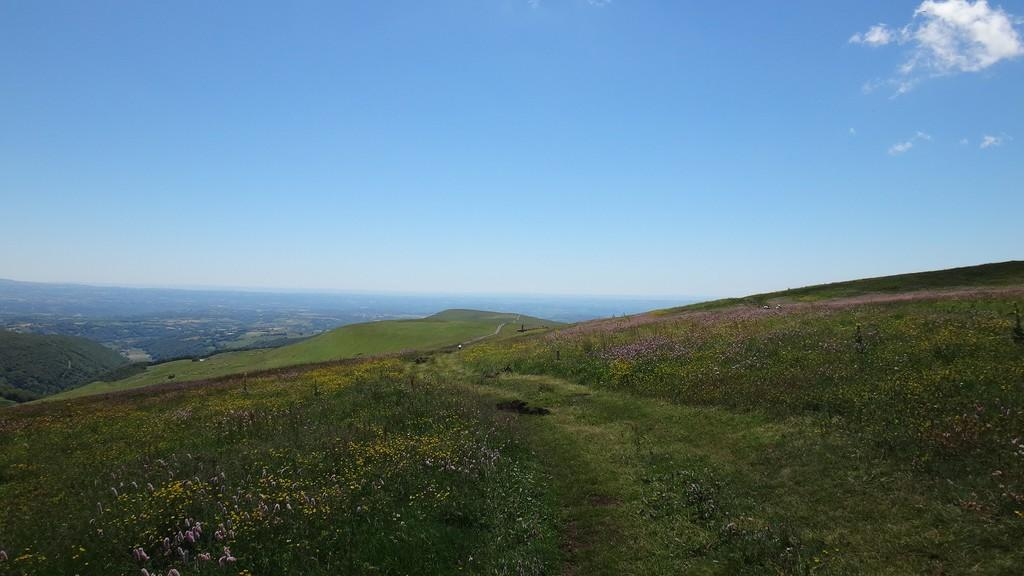What type of vegetation can be seen in the image? There are plants in the image. What type of ground cover is present in the image? There is grass in the image. What is visible at the top of the image? The sky is visible at the top of the image. How many icicles are hanging from the plants in the image? There are no icicles present in the image; it features plants and grass in a natural setting. What arithmetic problem is being solved by the plants in the image? There is no arithmetic problem being solved by the plants in the image; they are simply growing in their natural environment. 